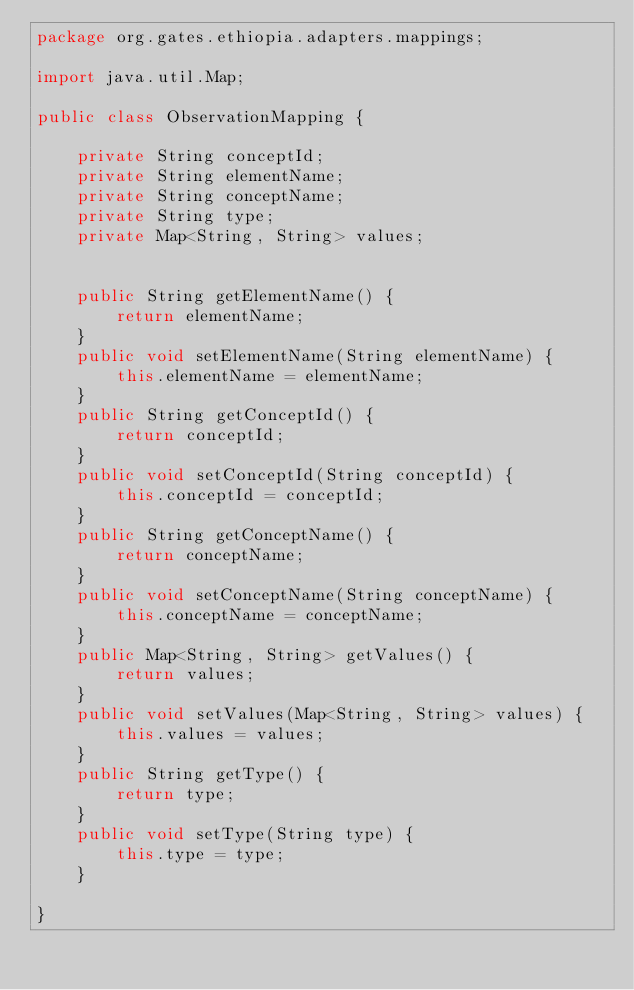Convert code to text. <code><loc_0><loc_0><loc_500><loc_500><_Java_>package org.gates.ethiopia.adapters.mappings;

import java.util.Map;

public class ObservationMapping {
    
    private String conceptId;
    private String elementName;
    private String conceptName;
    private String type;
    private Map<String, String> values;
    
    
    public String getElementName() {
        return elementName;
    }
    public void setElementName(String elementName) {
        this.elementName = elementName;
    }
    public String getConceptId() {
        return conceptId;
    }
    public void setConceptId(String conceptId) {
        this.conceptId = conceptId;
    }
    public String getConceptName() {
        return conceptName;
    }
    public void setConceptName(String conceptName) {
        this.conceptName = conceptName;
    }
    public Map<String, String> getValues() {
        return values;
    }
    public void setValues(Map<String, String> values) {
        this.values = values;
    }
    public String getType() {
        return type;
    }
    public void setType(String type) {
        this.type = type;
    }
    
}
</code> 